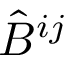<formula> <loc_0><loc_0><loc_500><loc_500>{ \hat { B } } ^ { i j }</formula> 